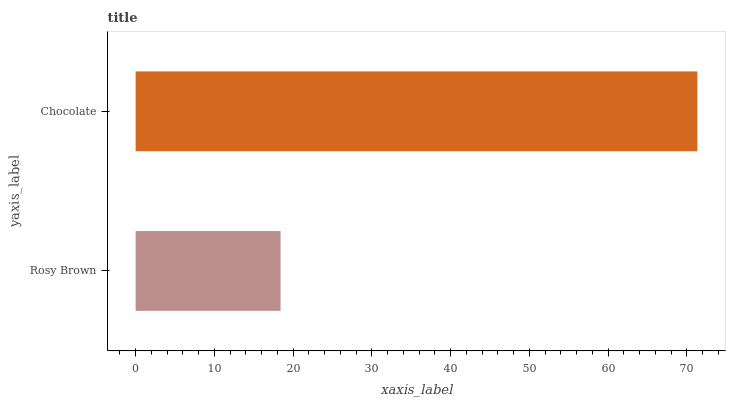Is Rosy Brown the minimum?
Answer yes or no. Yes. Is Chocolate the maximum?
Answer yes or no. Yes. Is Chocolate the minimum?
Answer yes or no. No. Is Chocolate greater than Rosy Brown?
Answer yes or no. Yes. Is Rosy Brown less than Chocolate?
Answer yes or no. Yes. Is Rosy Brown greater than Chocolate?
Answer yes or no. No. Is Chocolate less than Rosy Brown?
Answer yes or no. No. Is Chocolate the high median?
Answer yes or no. Yes. Is Rosy Brown the low median?
Answer yes or no. Yes. Is Rosy Brown the high median?
Answer yes or no. No. Is Chocolate the low median?
Answer yes or no. No. 